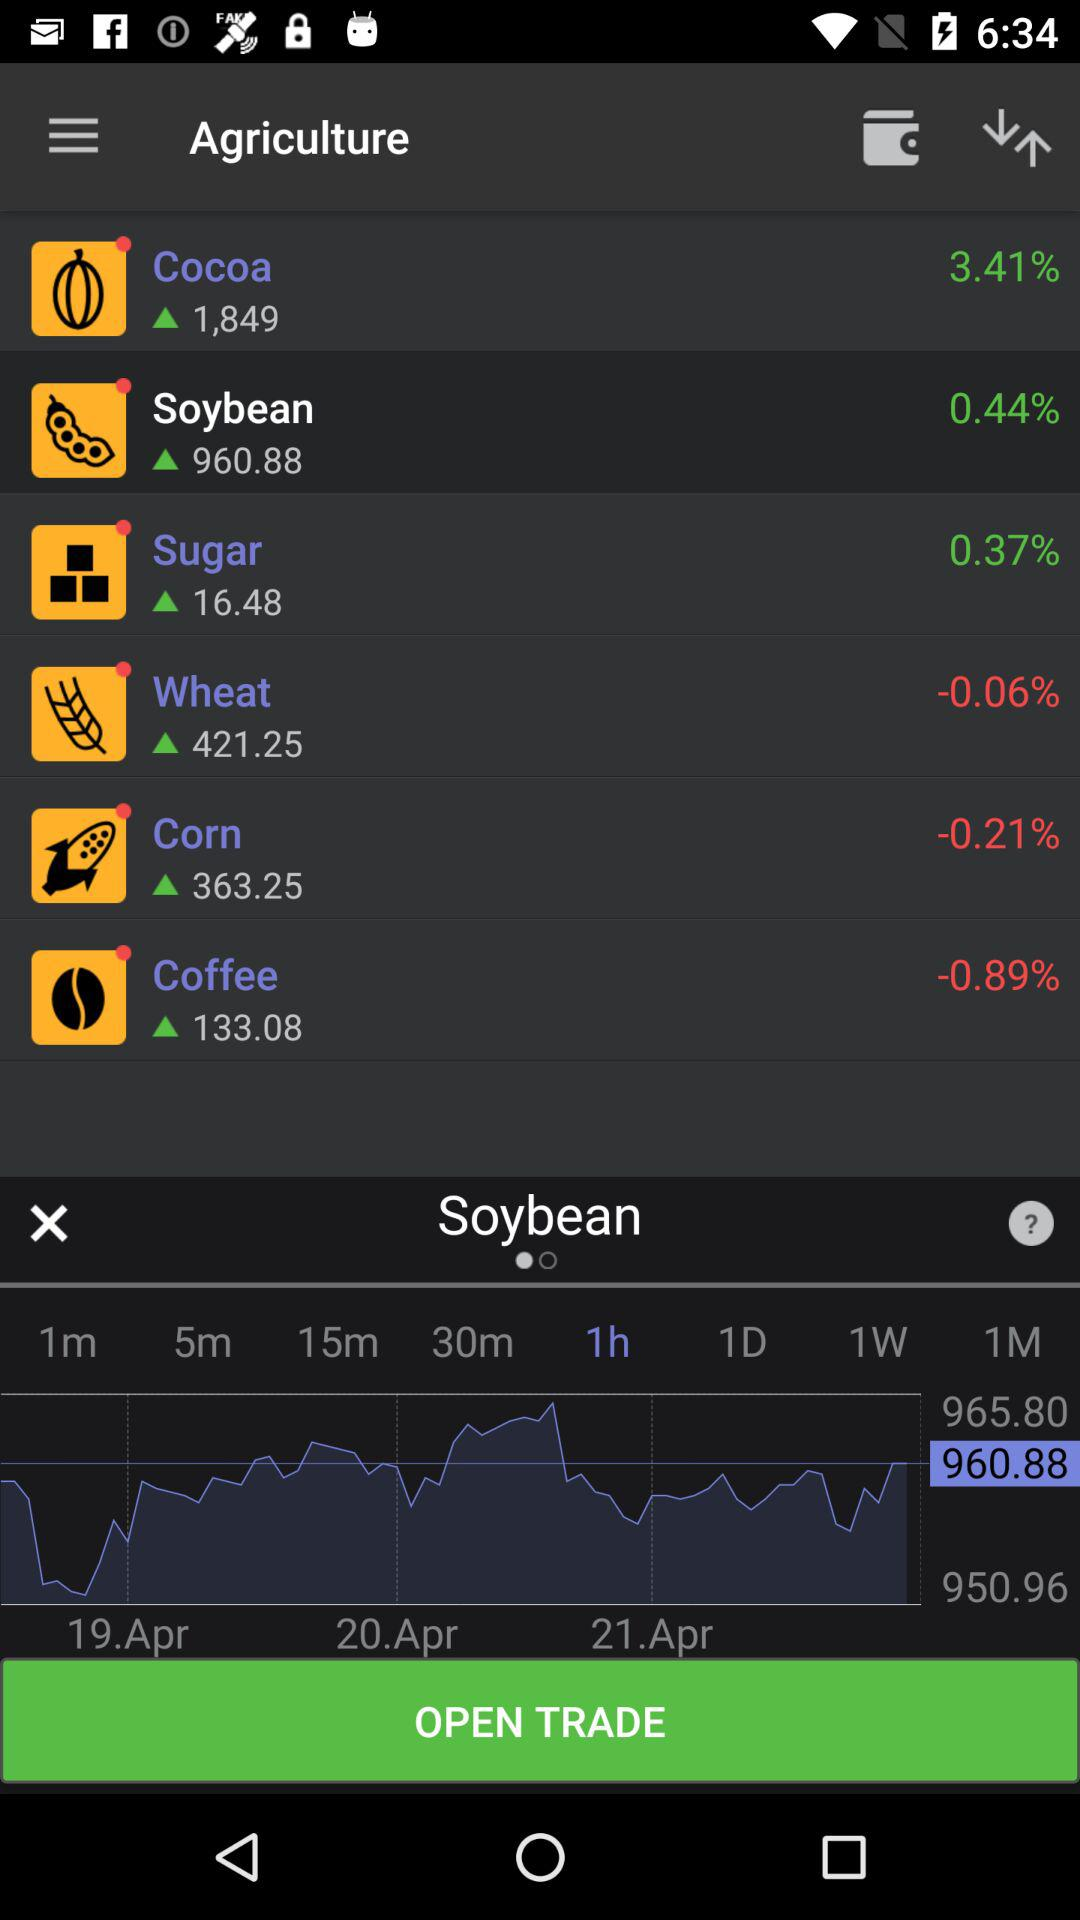Which option is selected in "Agriculture"? The selected option is "Soybean". 